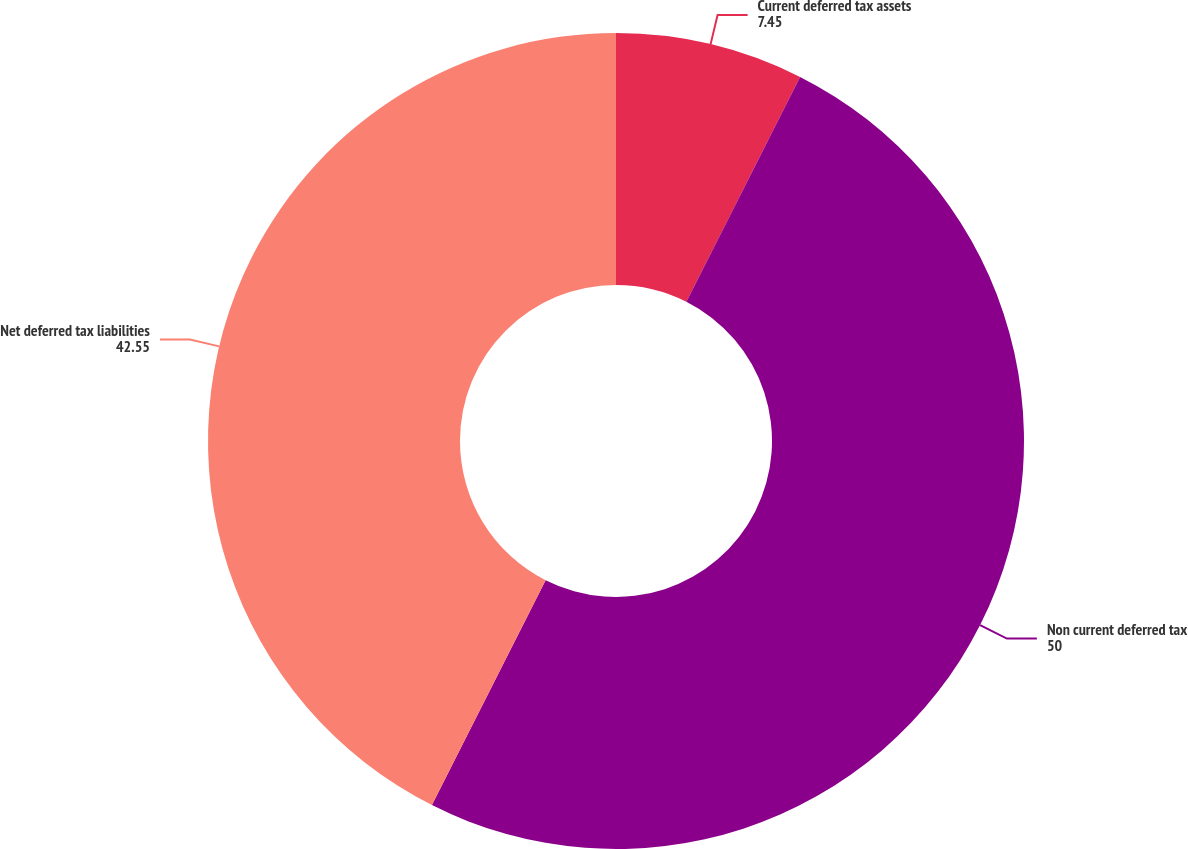<chart> <loc_0><loc_0><loc_500><loc_500><pie_chart><fcel>Current deferred tax assets<fcel>Non current deferred tax<fcel>Net deferred tax liabilities<nl><fcel>7.45%<fcel>50.0%<fcel>42.55%<nl></chart> 